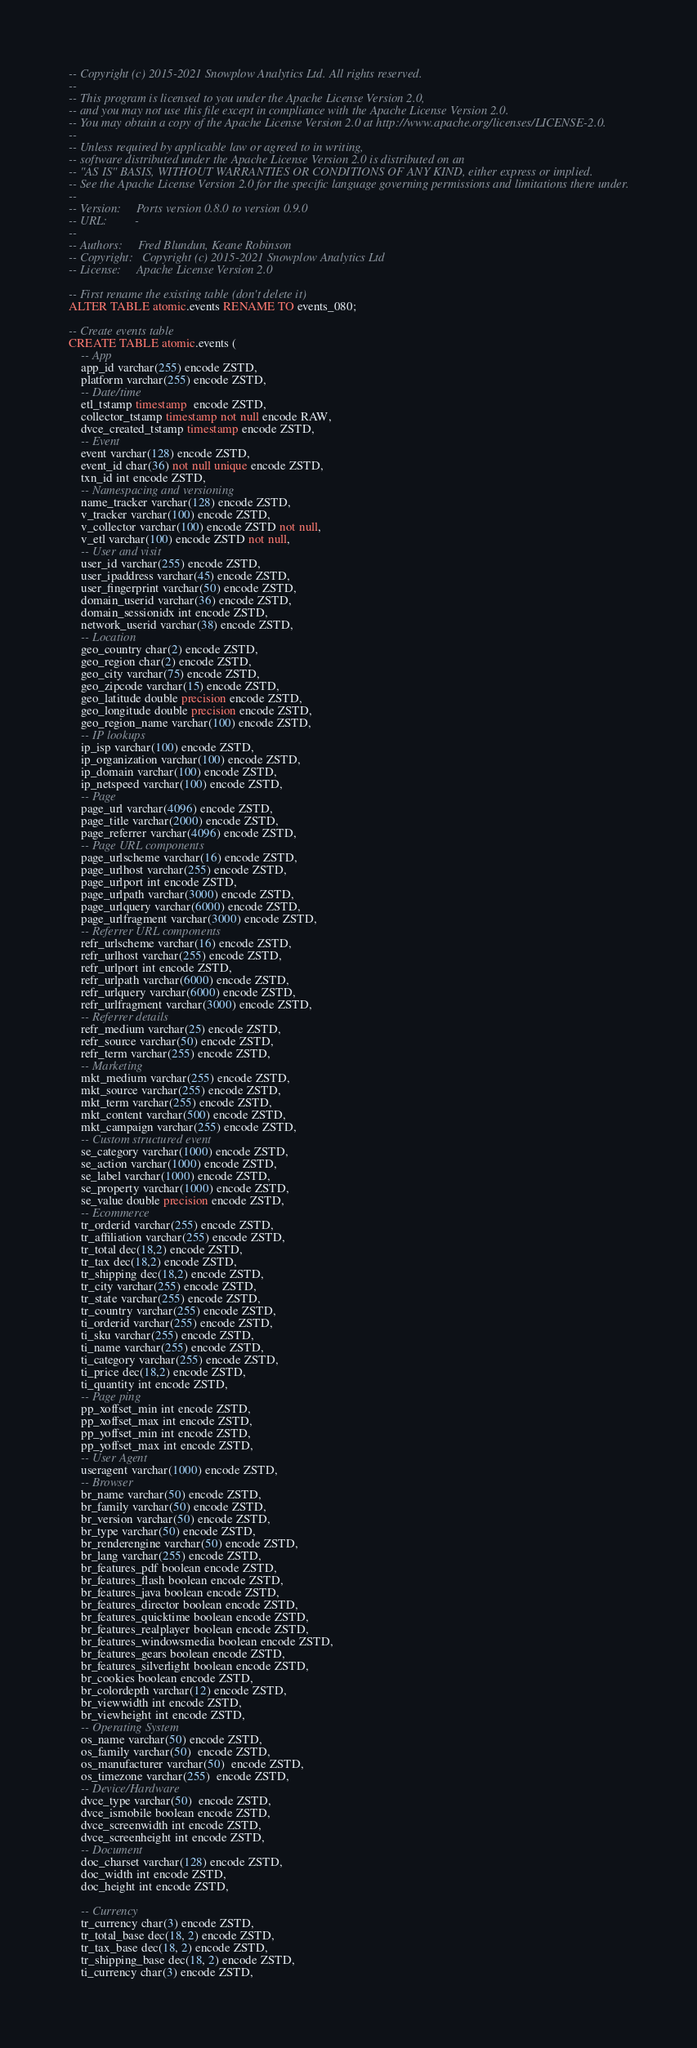Convert code to text. <code><loc_0><loc_0><loc_500><loc_500><_SQL_>-- Copyright (c) 2015-2021 Snowplow Analytics Ltd. All rights reserved.
--
-- This program is licensed to you under the Apache License Version 2.0,
-- and you may not use this file except in compliance with the Apache License Version 2.0.
-- You may obtain a copy of the Apache License Version 2.0 at http://www.apache.org/licenses/LICENSE-2.0.
--
-- Unless required by applicable law or agreed to in writing,
-- software distributed under the Apache License Version 2.0 is distributed on an
-- "AS IS" BASIS, WITHOUT WARRANTIES OR CONDITIONS OF ANY KIND, either express or implied.
-- See the Apache License Version 2.0 for the specific language governing permissions and limitations there under.
--
-- Version:     Ports version 0.8.0 to version 0.9.0
-- URL:         -
--
-- Authors:     Fred Blundun, Keane Robinson
-- Copyright:   Copyright (c) 2015-2021 Snowplow Analytics Ltd
-- License:     Apache License Version 2.0

-- First rename the existing table (don't delete it)
ALTER TABLE atomic.events RENAME TO events_080;

-- Create events table
CREATE TABLE atomic.events (
	-- App
	app_id varchar(255) encode ZSTD,
	platform varchar(255) encode ZSTD,
	-- Date/time
	etl_tstamp timestamp  encode ZSTD,
	collector_tstamp timestamp not null encode RAW,
	dvce_created_tstamp timestamp encode ZSTD,
	-- Event
	event varchar(128) encode ZSTD,
	event_id char(36) not null unique encode ZSTD,
	txn_id int encode ZSTD,
	-- Namespacing and versioning
	name_tracker varchar(128) encode ZSTD,
	v_tracker varchar(100) encode ZSTD,
	v_collector varchar(100) encode ZSTD not null,
	v_etl varchar(100) encode ZSTD not null,
	-- User and visit
	user_id varchar(255) encode ZSTD,
	user_ipaddress varchar(45) encode ZSTD,
	user_fingerprint varchar(50) encode ZSTD,
	domain_userid varchar(36) encode ZSTD,
	domain_sessionidx int encode ZSTD,
	network_userid varchar(38) encode ZSTD,
	-- Location
	geo_country char(2) encode ZSTD,
	geo_region char(2) encode ZSTD,
	geo_city varchar(75) encode ZSTD,
	geo_zipcode varchar(15) encode ZSTD,
	geo_latitude double precision encode ZSTD,
	geo_longitude double precision encode ZSTD,
	geo_region_name varchar(100) encode ZSTD,
	-- IP lookups
	ip_isp varchar(100) encode ZSTD,
	ip_organization varchar(100) encode ZSTD,
	ip_domain varchar(100) encode ZSTD,
	ip_netspeed varchar(100) encode ZSTD,
	-- Page
	page_url varchar(4096) encode ZSTD,
	page_title varchar(2000) encode ZSTD,
	page_referrer varchar(4096) encode ZSTD,
	-- Page URL components
	page_urlscheme varchar(16) encode ZSTD,
	page_urlhost varchar(255) encode ZSTD,
	page_urlport int encode ZSTD,
	page_urlpath varchar(3000) encode ZSTD,
	page_urlquery varchar(6000) encode ZSTD,
	page_urlfragment varchar(3000) encode ZSTD,
	-- Referrer URL components
	refr_urlscheme varchar(16) encode ZSTD,
	refr_urlhost varchar(255) encode ZSTD,
	refr_urlport int encode ZSTD,
	refr_urlpath varchar(6000) encode ZSTD,
	refr_urlquery varchar(6000) encode ZSTD,
	refr_urlfragment varchar(3000) encode ZSTD,
	-- Referrer details
	refr_medium varchar(25) encode ZSTD,
	refr_source varchar(50) encode ZSTD,
	refr_term varchar(255) encode ZSTD,
	-- Marketing
	mkt_medium varchar(255) encode ZSTD,
	mkt_source varchar(255) encode ZSTD,
	mkt_term varchar(255) encode ZSTD,
	mkt_content varchar(500) encode ZSTD,
	mkt_campaign varchar(255) encode ZSTD,
	-- Custom structured event
	se_category varchar(1000) encode ZSTD,
	se_action varchar(1000) encode ZSTD,
	se_label varchar(1000) encode ZSTD,
	se_property varchar(1000) encode ZSTD,
	se_value double precision encode ZSTD,
	-- Ecommerce
	tr_orderid varchar(255) encode ZSTD,
	tr_affiliation varchar(255) encode ZSTD,
	tr_total dec(18,2) encode ZSTD,
	tr_tax dec(18,2) encode ZSTD,
	tr_shipping dec(18,2) encode ZSTD,
	tr_city varchar(255) encode ZSTD,
	tr_state varchar(255) encode ZSTD,
	tr_country varchar(255) encode ZSTD,
	ti_orderid varchar(255) encode ZSTD,
	ti_sku varchar(255) encode ZSTD,
	ti_name varchar(255) encode ZSTD,
	ti_category varchar(255) encode ZSTD,
	ti_price dec(18,2) encode ZSTD,
	ti_quantity int encode ZSTD,
	-- Page ping
	pp_xoffset_min int encode ZSTD,
	pp_xoffset_max int encode ZSTD,
	pp_yoffset_min int encode ZSTD,
	pp_yoffset_max int encode ZSTD,
	-- User Agent
	useragent varchar(1000) encode ZSTD,
	-- Browser
	br_name varchar(50) encode ZSTD,
	br_family varchar(50) encode ZSTD,
	br_version varchar(50) encode ZSTD,
	br_type varchar(50) encode ZSTD,
	br_renderengine varchar(50) encode ZSTD,
	br_lang varchar(255) encode ZSTD,
	br_features_pdf boolean encode ZSTD,
	br_features_flash boolean encode ZSTD,
	br_features_java boolean encode ZSTD,
	br_features_director boolean encode ZSTD,
	br_features_quicktime boolean encode ZSTD,
	br_features_realplayer boolean encode ZSTD,
	br_features_windowsmedia boolean encode ZSTD,
	br_features_gears boolean encode ZSTD,
	br_features_silverlight boolean encode ZSTD,
	br_cookies boolean encode ZSTD,
	br_colordepth varchar(12) encode ZSTD,
	br_viewwidth int encode ZSTD,
	br_viewheight int encode ZSTD,
	-- Operating System
	os_name varchar(50) encode ZSTD,
	os_family varchar(50)  encode ZSTD,
	os_manufacturer varchar(50)  encode ZSTD,
	os_timezone varchar(255)  encode ZSTD,
	-- Device/Hardware
	dvce_type varchar(50)  encode ZSTD,
	dvce_ismobile boolean encode ZSTD,
	dvce_screenwidth int encode ZSTD,
	dvce_screenheight int encode ZSTD,
	-- Document
	doc_charset varchar(128) encode ZSTD,
	doc_width int encode ZSTD,
	doc_height int encode ZSTD,

	-- Currency
	tr_currency char(3) encode ZSTD,
	tr_total_base dec(18, 2) encode ZSTD,
	tr_tax_base dec(18, 2) encode ZSTD,
	tr_shipping_base dec(18, 2) encode ZSTD,
	ti_currency char(3) encode ZSTD,</code> 